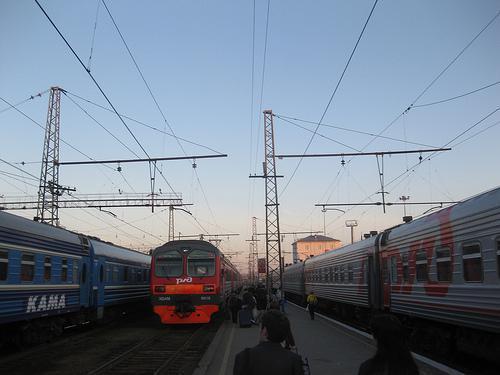How many trains are there?
Give a very brief answer. 3. 